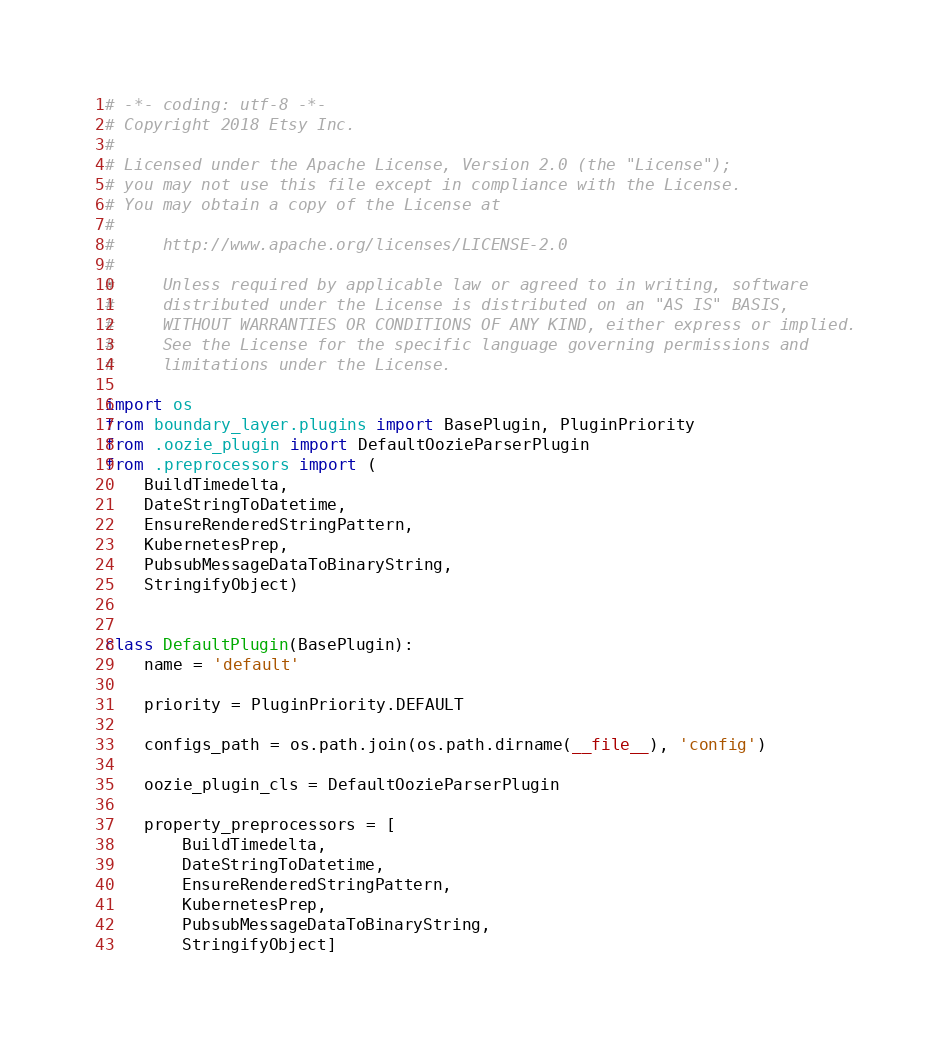Convert code to text. <code><loc_0><loc_0><loc_500><loc_500><_Python_># -*- coding: utf-8 -*-
# Copyright 2018 Etsy Inc.
#
# Licensed under the Apache License, Version 2.0 (the "License");
# you may not use this file except in compliance with the License.
# You may obtain a copy of the License at
#
#     http://www.apache.org/licenses/LICENSE-2.0
#
#     Unless required by applicable law or agreed to in writing, software
#     distributed under the License is distributed on an "AS IS" BASIS,
#     WITHOUT WARRANTIES OR CONDITIONS OF ANY KIND, either express or implied.
#     See the License for the specific language governing permissions and
#     limitations under the License.

import os
from boundary_layer.plugins import BasePlugin, PluginPriority
from .oozie_plugin import DefaultOozieParserPlugin
from .preprocessors import (
    BuildTimedelta,
    DateStringToDatetime,
    EnsureRenderedStringPattern,
    KubernetesPrep,
    PubsubMessageDataToBinaryString,
    StringifyObject)


class DefaultPlugin(BasePlugin):
    name = 'default'

    priority = PluginPriority.DEFAULT

    configs_path = os.path.join(os.path.dirname(__file__), 'config')

    oozie_plugin_cls = DefaultOozieParserPlugin

    property_preprocessors = [
        BuildTimedelta,
        DateStringToDatetime,
        EnsureRenderedStringPattern,
        KubernetesPrep,
        PubsubMessageDataToBinaryString,
        StringifyObject]
</code> 